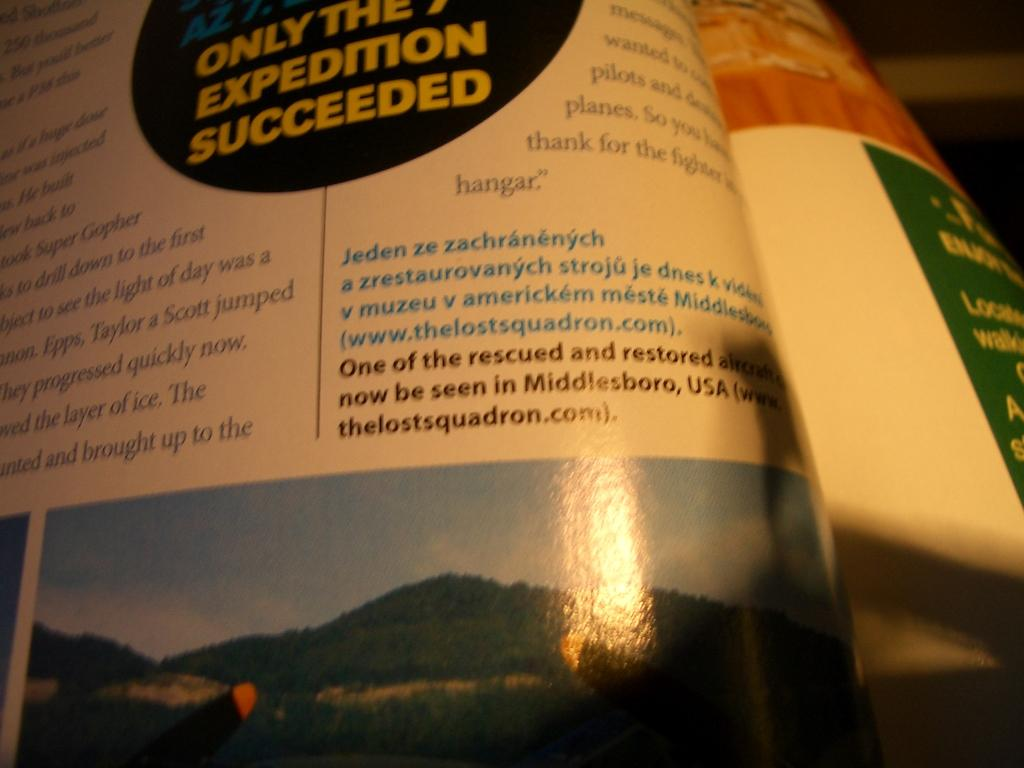<image>
Write a terse but informative summary of the picture. An open magazine with Expedition Succeeded on it. 